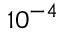Convert formula to latex. <formula><loc_0><loc_0><loc_500><loc_500>1 0 ^ { - 4 }</formula> 